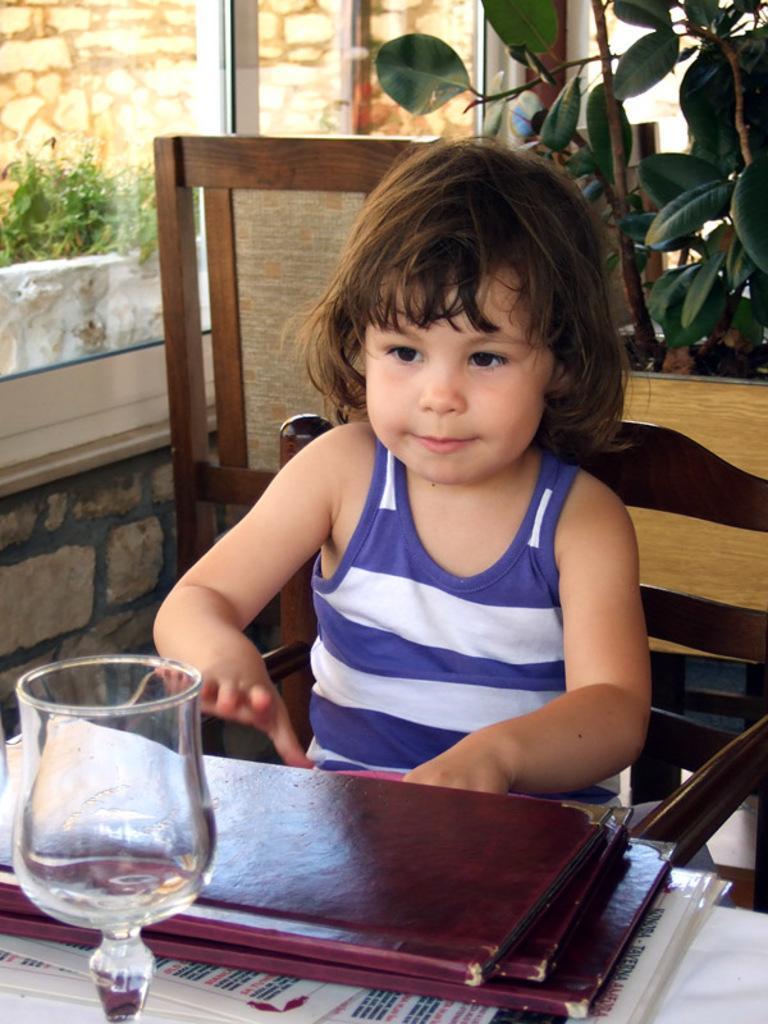Can you describe this image briefly? In this picture we can see a little girl in blue and white dress sitting on the chair in front of a table and on the table on which we have some menu cards and a glass and behind her there is a plant. 